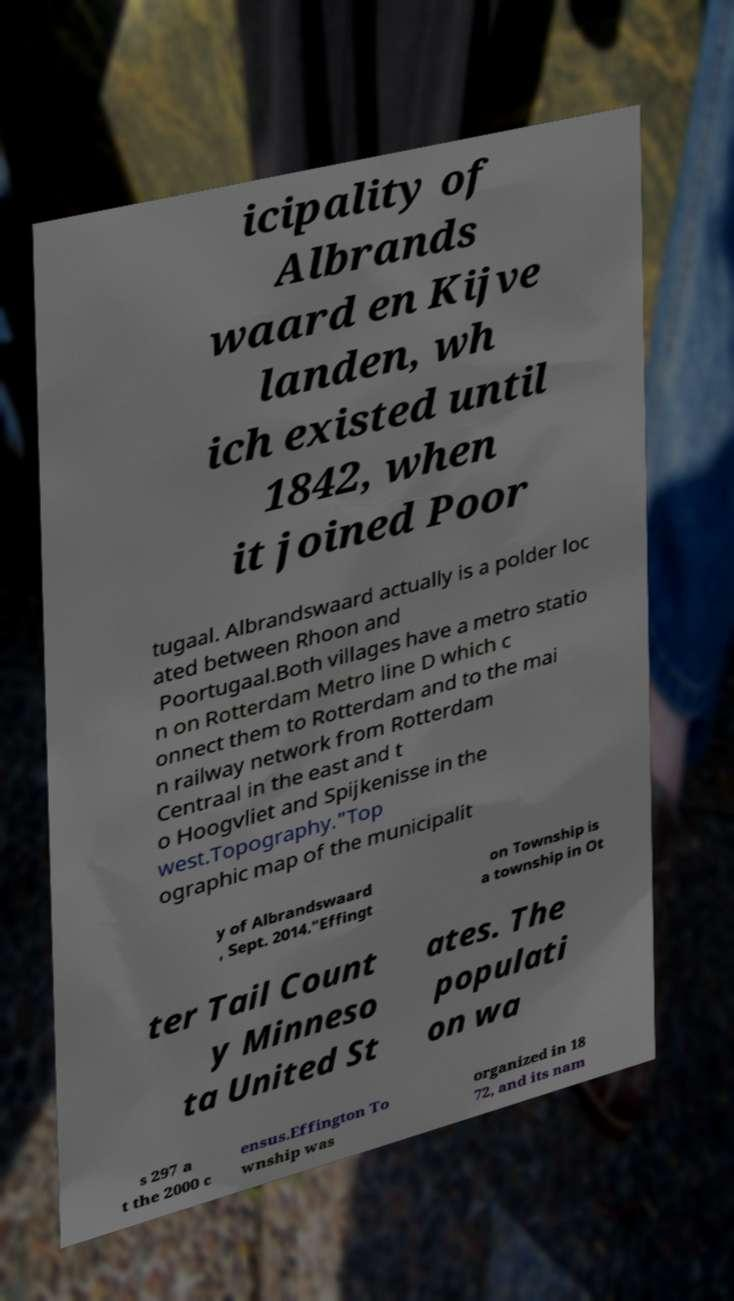There's text embedded in this image that I need extracted. Can you transcribe it verbatim? icipality of Albrands waard en Kijve landen, wh ich existed until 1842, when it joined Poor tugaal. Albrandswaard actually is a polder loc ated between Rhoon and Poortugaal.Both villages have a metro statio n on Rotterdam Metro line D which c onnect them to Rotterdam and to the mai n railway network from Rotterdam Centraal in the east and t o Hoogvliet and Spijkenisse in the west.Topography."Top ographic map of the municipalit y of Albrandswaard , Sept. 2014."Effingt on Township is a township in Ot ter Tail Count y Minneso ta United St ates. The populati on wa s 297 a t the 2000 c ensus.Effington To wnship was organized in 18 72, and its nam 